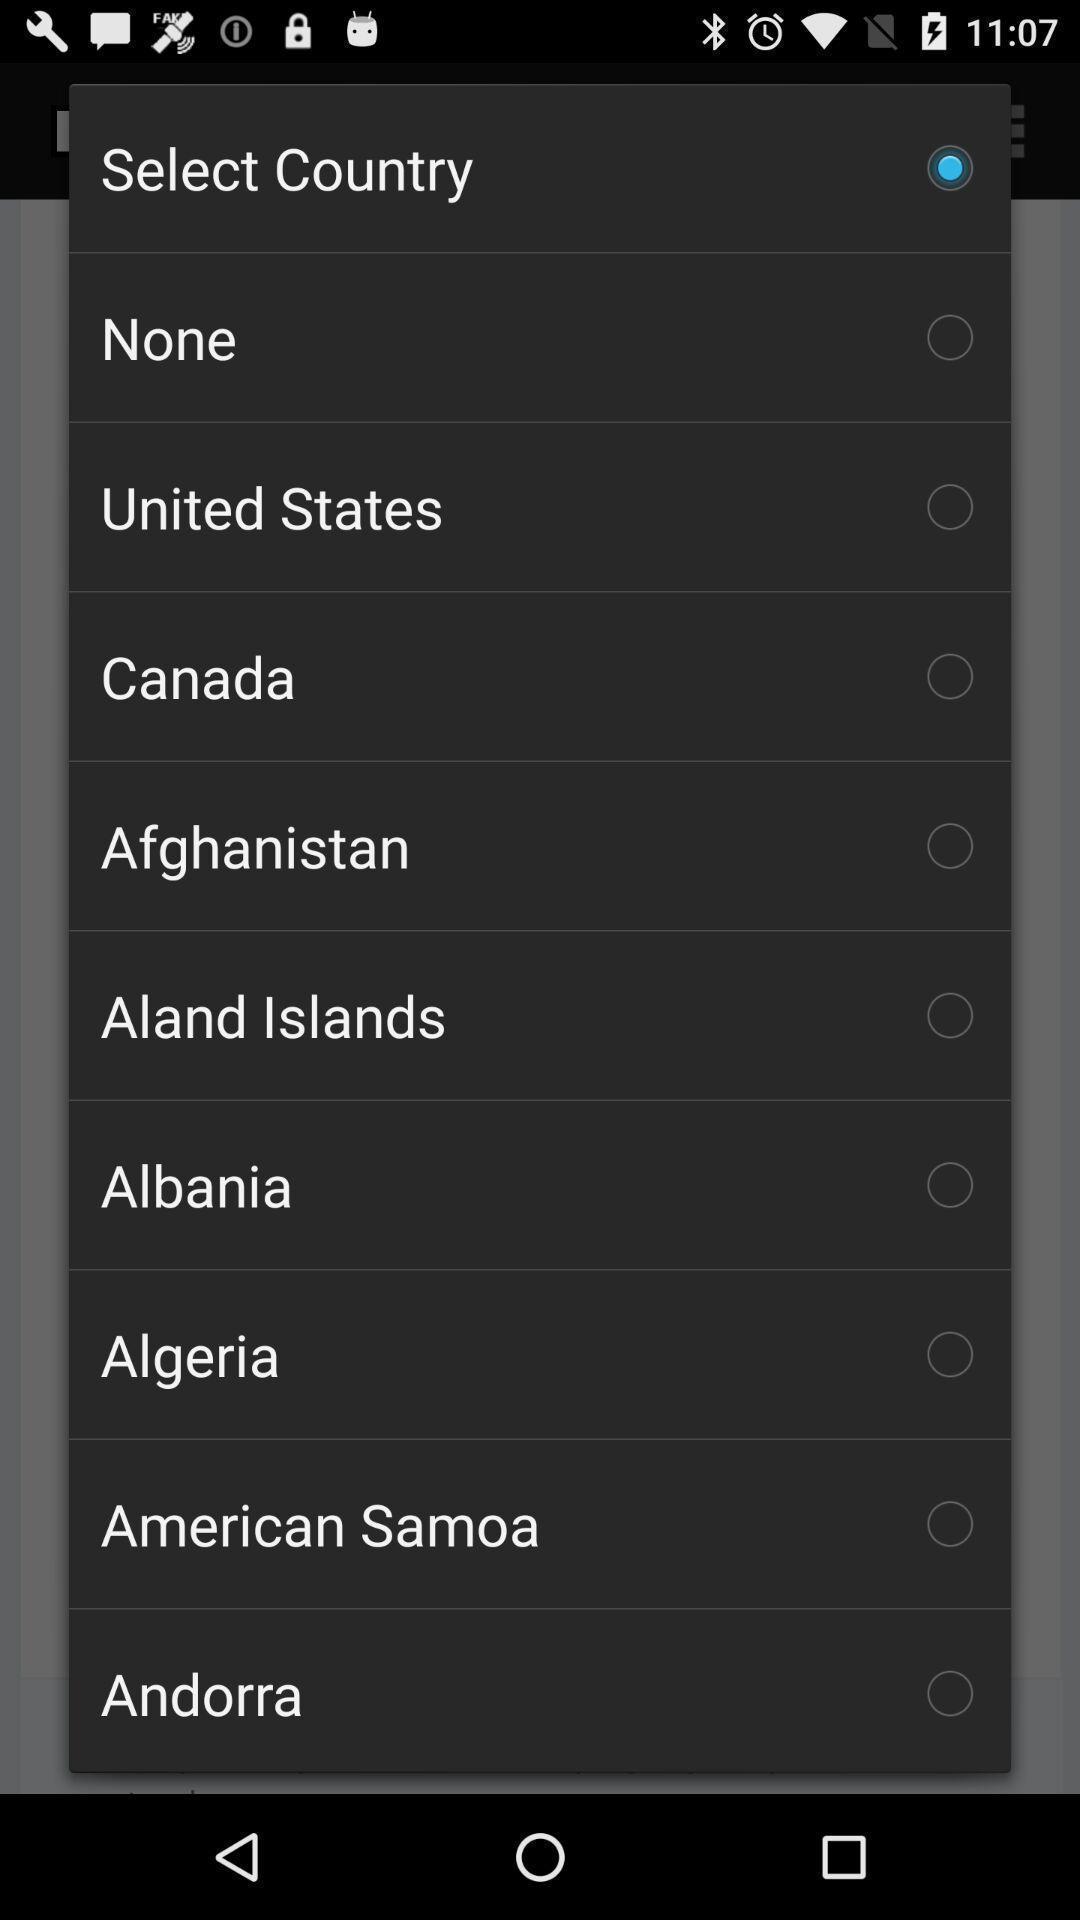Explain the elements present in this screenshot. Popup of different countries to select in the application. 